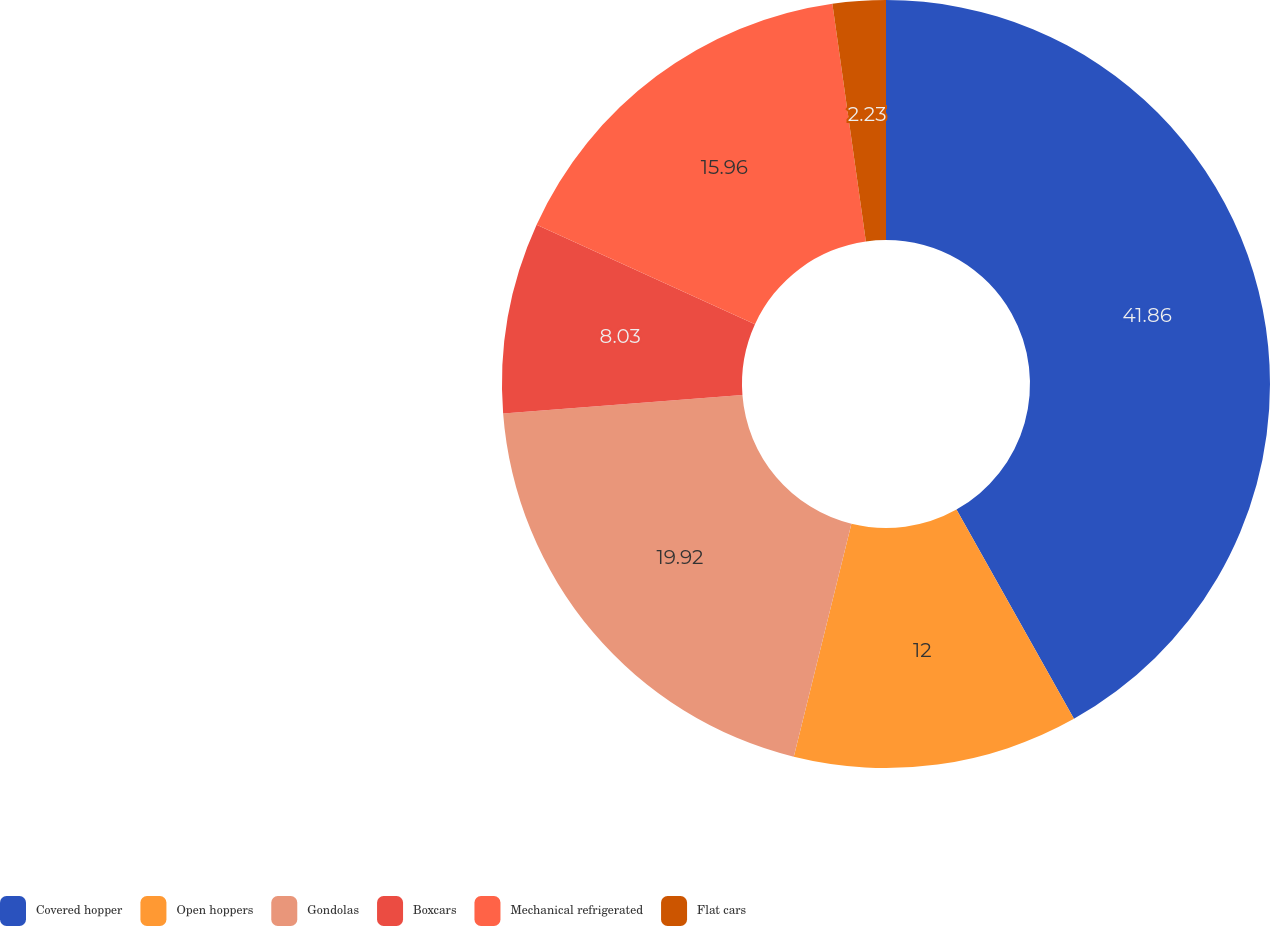Convert chart to OTSL. <chart><loc_0><loc_0><loc_500><loc_500><pie_chart><fcel>Covered hopper<fcel>Open hoppers<fcel>Gondolas<fcel>Boxcars<fcel>Mechanical refrigerated<fcel>Flat cars<nl><fcel>41.86%<fcel>12.0%<fcel>19.92%<fcel>8.03%<fcel>15.96%<fcel>2.23%<nl></chart> 